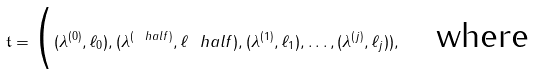<formula> <loc_0><loc_0><loc_500><loc_500>\mathfrak { t } = \Big ( ( \lambda ^ { ( 0 ) } , \ell _ { 0 } ) , ( \lambda ^ { ( \ h a l f ) } , \ell _ { \ } h a l f ) , ( \lambda ^ { ( 1 ) } , \ell _ { 1 } ) , \dots , ( \lambda ^ { ( j ) } , \ell _ { j } ) ) , \quad \text {where}</formula> 